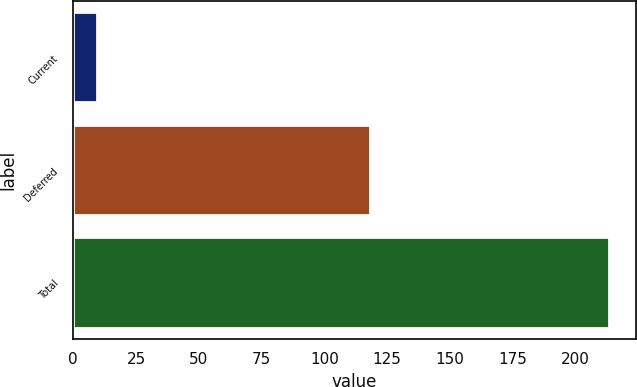<chart> <loc_0><loc_0><loc_500><loc_500><bar_chart><fcel>Current<fcel>Deferred<fcel>Total<nl><fcel>9.4<fcel>118.1<fcel>213.3<nl></chart> 